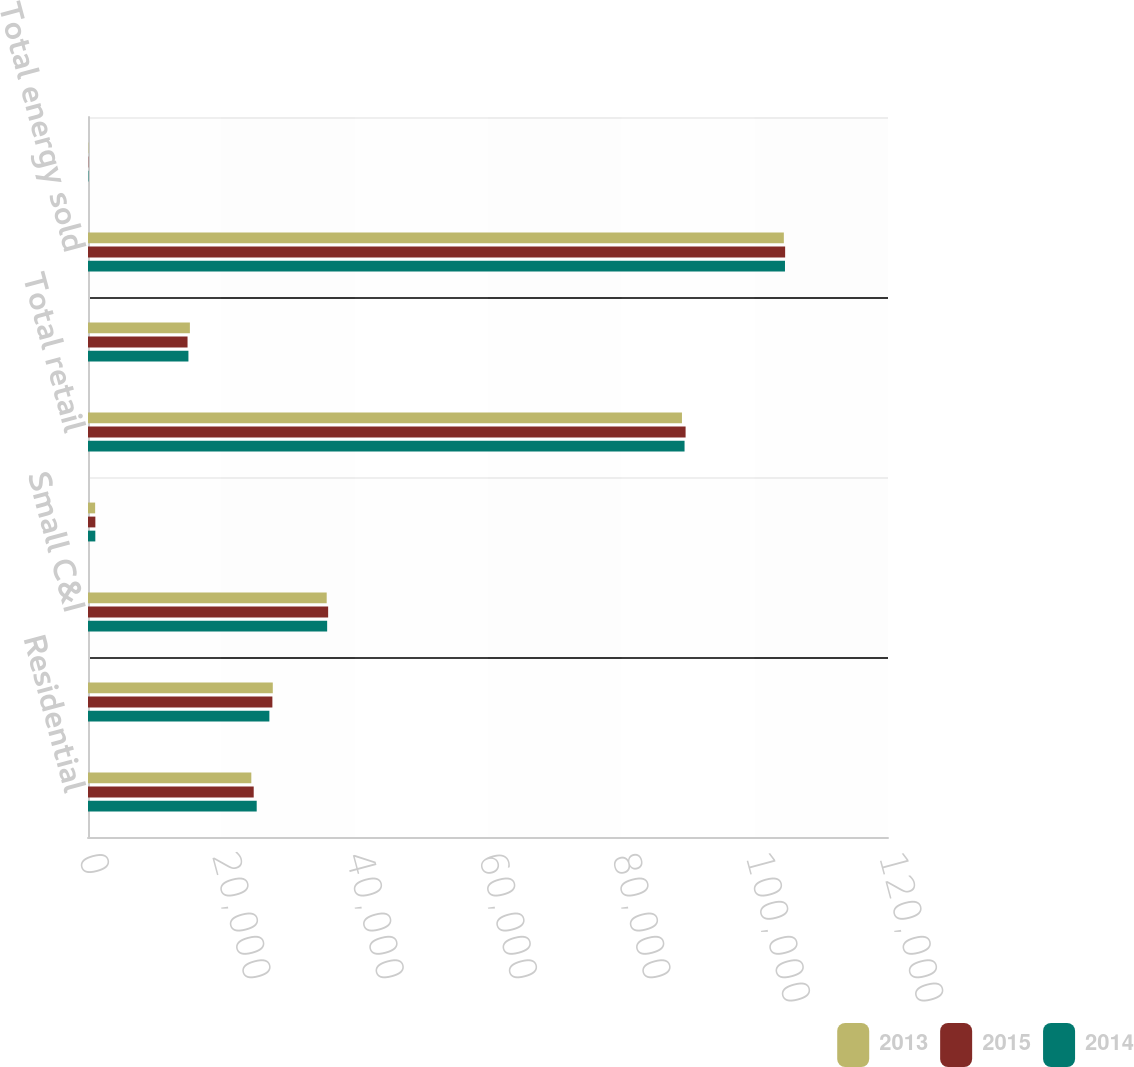Convert chart to OTSL. <chart><loc_0><loc_0><loc_500><loc_500><stacked_bar_chart><ecel><fcel>Residential<fcel>Large C&I<fcel>Small C&I<fcel>Public authorities and other<fcel>Total retail<fcel>Sales for resale<fcel>Total energy sold<fcel>Wholesale<nl><fcel>2013<fcel>24498<fcel>27719<fcel>35806<fcel>1071<fcel>89094<fcel>15283<fcel>104377<fcel>47<nl><fcel>2015<fcel>24857<fcel>27657<fcel>36022<fcel>1104<fcel>89640<fcel>14931<fcel>104571<fcel>44<nl><fcel>2014<fcel>25306<fcel>27206<fcel>35873<fcel>1098<fcel>89483<fcel>15065<fcel>104548<fcel>65<nl></chart> 